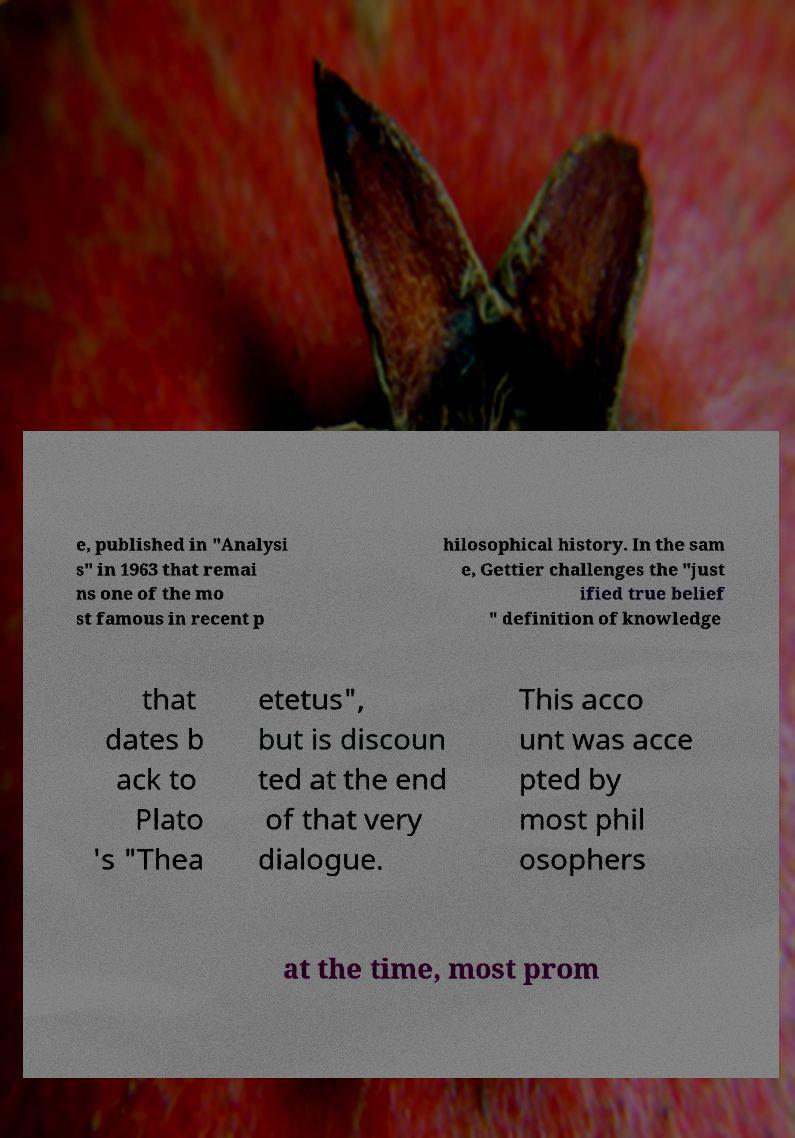There's text embedded in this image that I need extracted. Can you transcribe it verbatim? e, published in "Analysi s" in 1963 that remai ns one of the mo st famous in recent p hilosophical history. In the sam e, Gettier challenges the "just ified true belief " definition of knowledge that dates b ack to Plato 's "Thea etetus", but is discoun ted at the end of that very dialogue. This acco unt was acce pted by most phil osophers at the time, most prom 